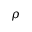Convert formula to latex. <formula><loc_0><loc_0><loc_500><loc_500>\rho</formula> 